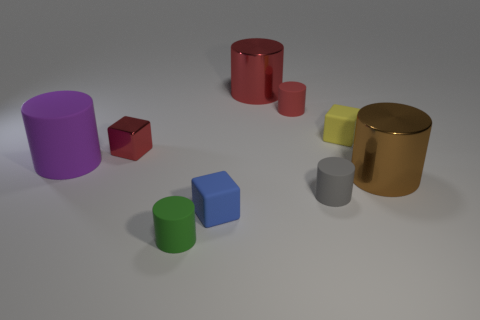Subtract all rubber blocks. How many blocks are left? 1 Add 1 big red blocks. How many objects exist? 10 Subtract all red cylinders. How many cylinders are left? 4 Subtract all cylinders. How many objects are left? 3 Subtract 5 cylinders. How many cylinders are left? 1 Subtract all brown cubes. Subtract all cyan cylinders. How many cubes are left? 3 Add 5 tiny red cubes. How many tiny red cubes are left? 6 Add 8 blue objects. How many blue objects exist? 9 Subtract 0 blue cylinders. How many objects are left? 9 Subtract all gray spheres. How many purple cubes are left? 0 